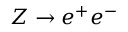<formula> <loc_0><loc_0><loc_500><loc_500>Z \rightarrow e ^ { + } e ^ { - }</formula> 